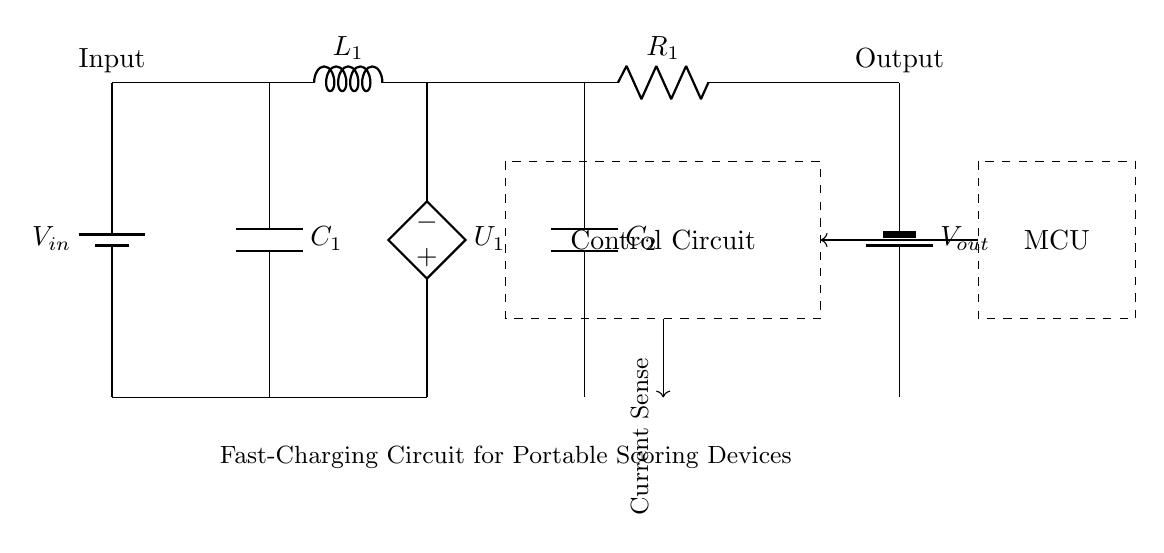What is the input component in this circuit? The input component is a battery, denoted as V_in, which provides the necessary voltage to the circuit.
Answer: Battery What does the control circuit do? The control circuit manages the operation of the fast-charging process, ensuring the device charges at the correct rate and monitoring current flow.
Answer: Management What is the value of the voltage regulator? The voltage regulator is shown as U_1 in the diagram, and it adjusts the voltage level required for charging.
Answer: Voltage regulator How many capacitors are there in the circuit? The circuit includes two capacitors labeled as C_1 and C_2, which are essential for filtering and energy storage during the charging process.
Answer: Two What type of current sensing is used in the circuit? The circuit employs a current sense mechanism indicated by the arrow pointing towards the current sense label, allowing it to monitor the charging current effectively.
Answer: Current sense Which component provides the output voltage in this circuit? The output component is a battery, labeled V_out, which delivers the regulated voltage to the portable scoring device.
Answer: Battery What is the purpose of the inductor in this circuit? The inductor, labeled as L_1, is used to smooth out the current fluctuations during the charging cycle and provides energy storage capability.
Answer: Smoothing 